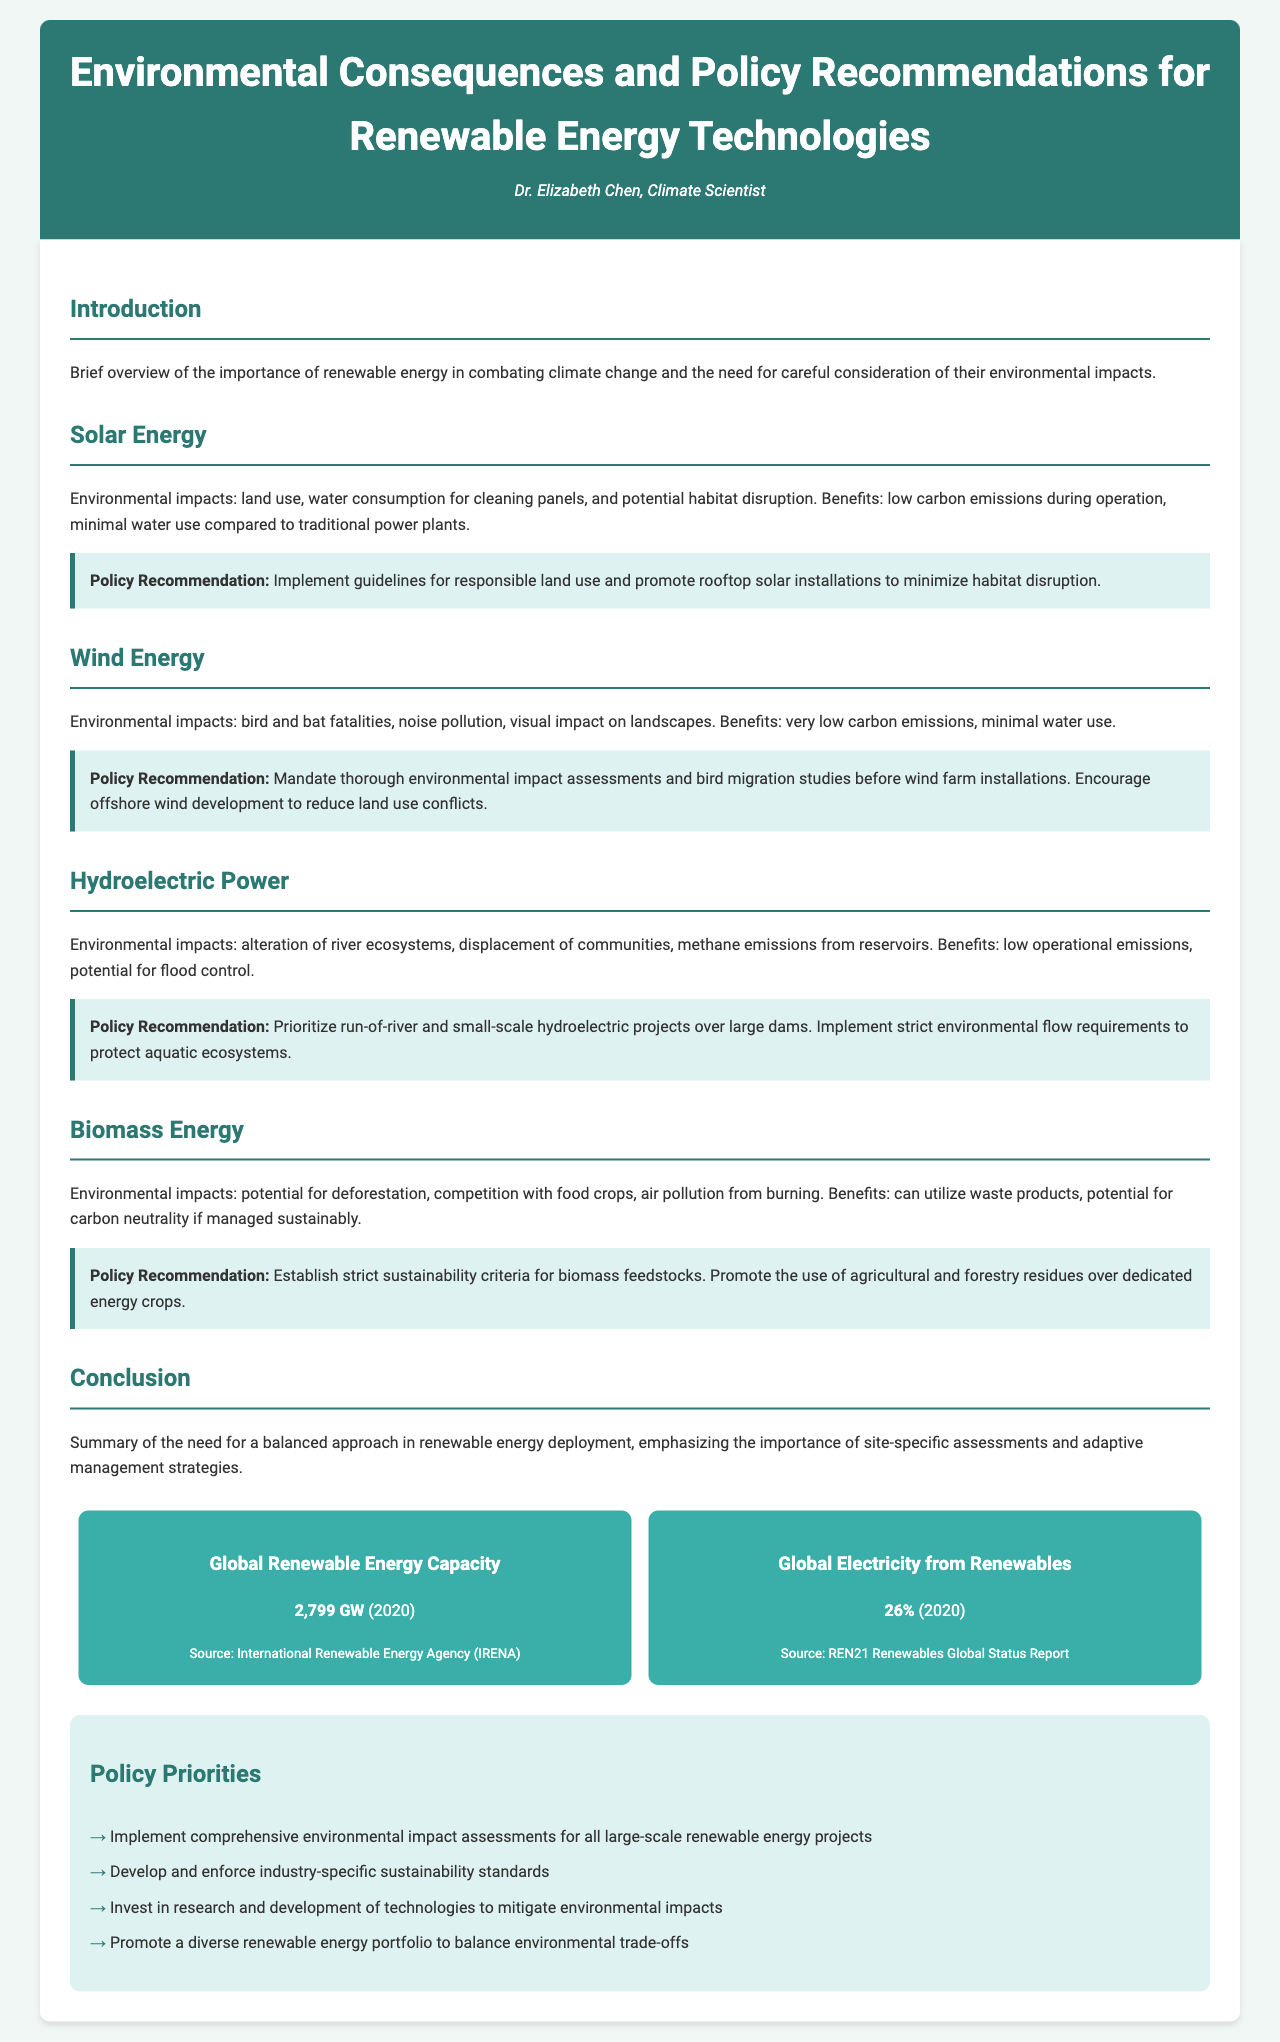What are the benefits of solar energy? The benefits of solar energy include low carbon emissions during operation and minimal water use compared to traditional power plants.
Answer: Low carbon emissions, minimal water use What should be prioritized in hydroelectric projects? The document recommends prioritizing run-of-river and small-scale hydroelectric projects over large dams.
Answer: Run-of-river and small-scale What is the global renewable energy capacity as of 2020? The document states that the global renewable energy capacity is 2,799 GW in 2020.
Answer: 2,799 GW Which environmental impact is associated with wind energy? Bird and bat fatalities are listed as an environmental impact of wind energy.
Answer: Bird and bat fatalities What type of assessments are recommended for wind farm installations? The document suggests mandating thorough environmental impact assessments and bird migration studies.
Answer: Environmental impact assessments, bird migration studies What is one potential environmental impact of biomass energy? The potential for deforestation is mentioned as an environmental impact of biomass energy.
Answer: Deforestation What is a key policy priority mentioned in the document? One of the policy priorities is to implement comprehensive environmental impact assessments for all large-scale renewable energy projects.
Answer: Implement comprehensive environmental impact assessments What are the benefits of hydroelectric power? The benefits of hydroelectric power include low operational emissions and the potential for flood control.
Answer: Low operational emissions, potential for flood control What does the conclusion emphasize? The conclusion emphasizes the importance of site-specific assessments and adaptive management strategies.
Answer: Site-specific assessments, adaptive management strategies 